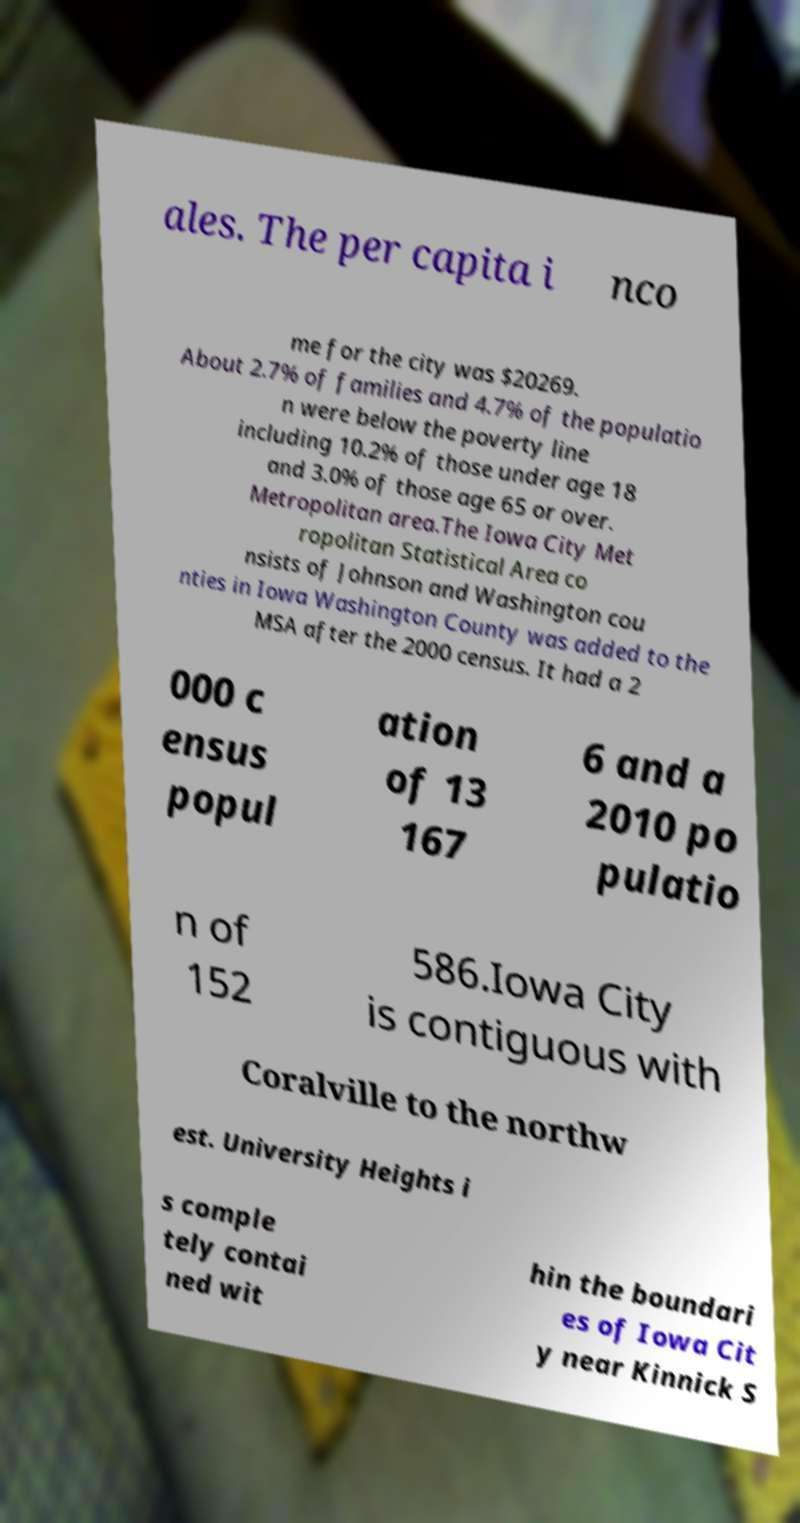For documentation purposes, I need the text within this image transcribed. Could you provide that? ales. The per capita i nco me for the city was $20269. About 2.7% of families and 4.7% of the populatio n were below the poverty line including 10.2% of those under age 18 and 3.0% of those age 65 or over. Metropolitan area.The Iowa City Met ropolitan Statistical Area co nsists of Johnson and Washington cou nties in Iowa Washington County was added to the MSA after the 2000 census. It had a 2 000 c ensus popul ation of 13 167 6 and a 2010 po pulatio n of 152 586.Iowa City is contiguous with Coralville to the northw est. University Heights i s comple tely contai ned wit hin the boundari es of Iowa Cit y near Kinnick S 